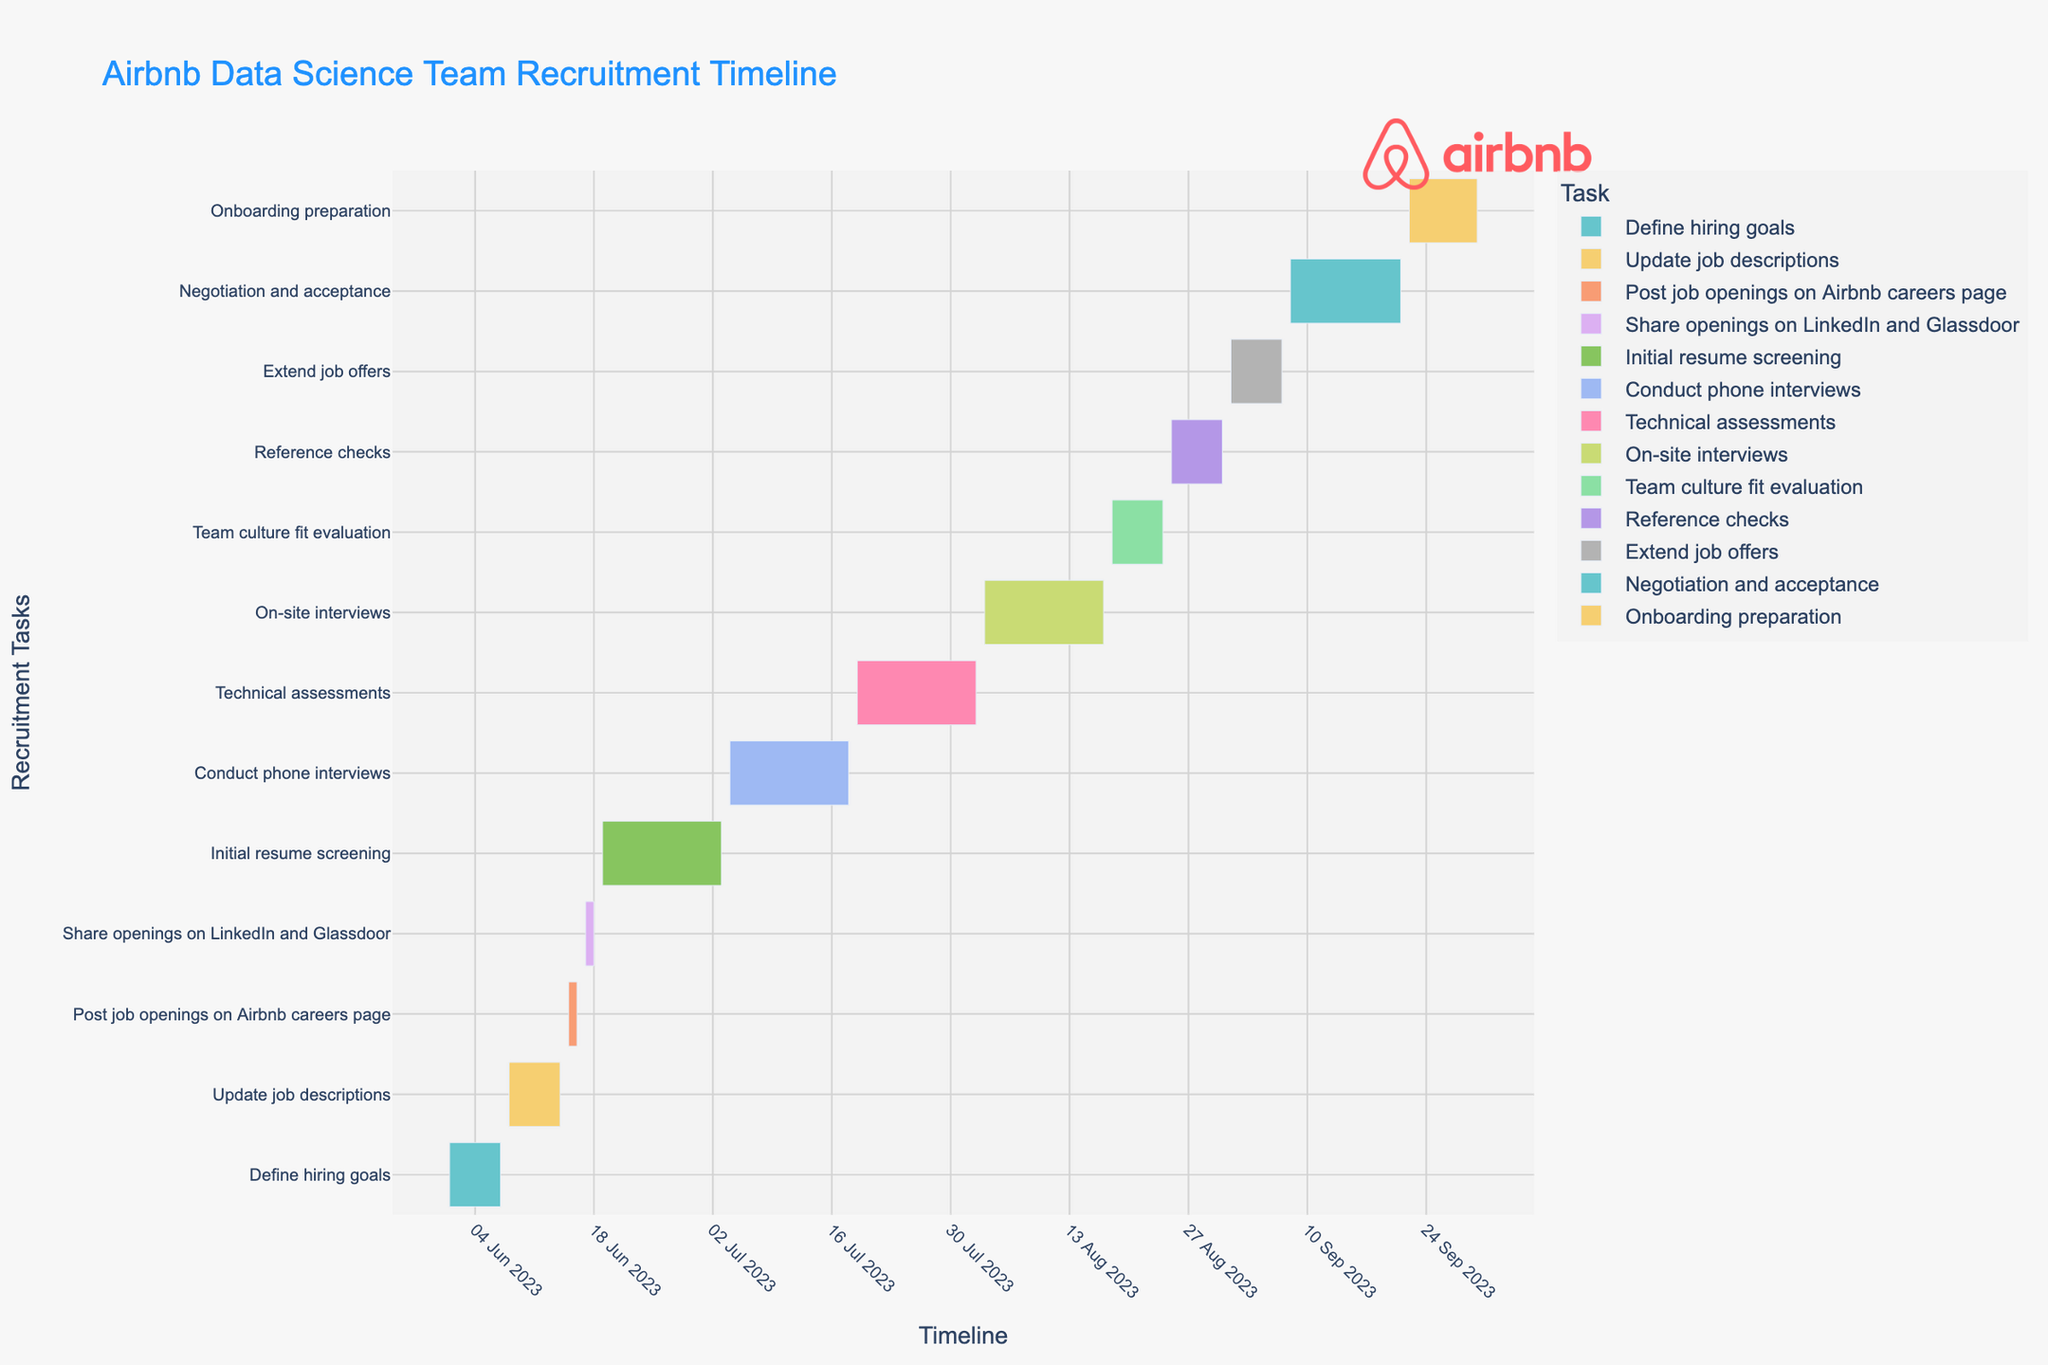What is the title of the Gantt Chart? The title of the Gantt Chart is displayed at the top of the figure and is usually set to describe the main topic or purpose of the chart. Here, the title is "Airbnb Data Science Team Recruitment Timeline."
Answer: Airbnb Data Science Team Recruitment Timeline How is the x-axis labeled? The x-axis, at the bottom of the chart, typically indicates the time scale for a Gantt Chart. In this figure, the x-axis is labeled to show the timeline with date formats indicating start and end dates of tasks.
Answer: Timeline Which task takes the longest to complete and how many days does it span? By checking the horizontal bars representing each task, identify the longest bar. The "Initial resume screening" has the longest bar. It spans from June 19, 2023, to July 3, 2023. So, it takes 15 days (including both start and end dates).
Answer: Initial resume screening; 15 days Which task directly follows "Post job openings on Airbnb careers page"? Observing the sequential order of the tasks, the "Share openings on LinkedIn and Glassdoor" directly follows the "Post job openings on Airbnb careers page."
Answer: Share openings on LinkedIn and Glassdoor How many tasks are planned to be completed by the end of June 2023? Look at the end dates of each task. The tasks completed by the end of June 2023 are: Define hiring goals, Update job descriptions, Post job openings on Airbnb careers page, Share openings on LinkedIn and Glassdoor, and Initial resume screening.
Answer: 5 tasks Compare the duration of "Conduct phone interviews" and "Technical assessments." Which one takes longer and by how many days? The duration for "Conduct phone interviews" (July 4 to July 18) is 15 days. The duration for "Technical assessments" (July 19 to August 2) is also 15 days. Comparing these durations, both tasks take the same amount of time.
Answer: Both take the same time; 15 days What is the last task in the recruitment timeline and when does it end? The last task usually appears at the bottom of the y-axis or timeline. Here, "Onboarding preparation" is the last task which ends on September 30, 2023.
Answer: Onboarding preparation; September 30, 2023 Calculate the total duration of the recruitment process from the first task to the last task. The recruitment process starts with "Define hiring goals" on June 1, 2023, and ends with "Onboarding preparation" on September 30, 2023. Calculating the duration between these dates: from June 1 to September 30 is 122 days.
Answer: 122 days Which two tasks overlap in August 2023 and how do their timelines compare? By inspecting the tasks occurring in August, "Technical assessments" (ends August 2), "On-site interviews" (August 3 to August 17), and "Team culture fit evaluation" (August 18 to August 24) are some tasks running in August. "On-site interviews" and "Team culture fit evaluation" overlap around mid-August. "On-site interviews" runs for a longer duration of 15 days compared to the 7 days of "Team culture fit evaluation."
Answer: On-site interviews and Team culture fit evaluation; "On-site interviews" is longer How many days does the negotiation and acceptance phase last? The "Negotiation and acceptance" task spans from September 8 to September 21. Counting these days including the start and end dates: from September 8 to September 21 is 14 days.
Answer: 14 days 